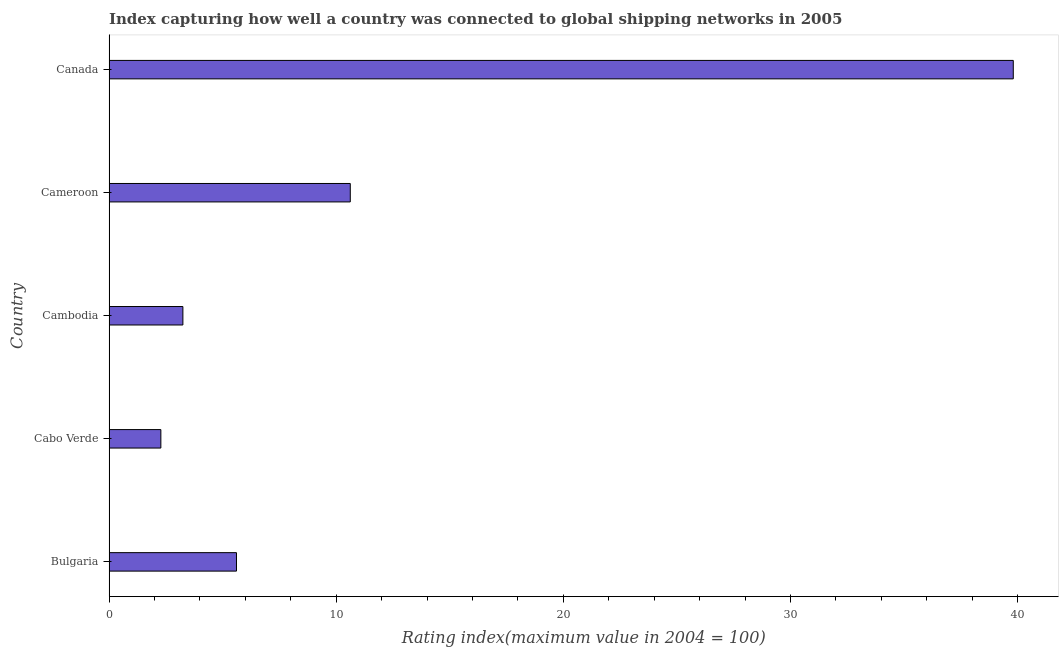Does the graph contain grids?
Keep it short and to the point. No. What is the title of the graph?
Provide a short and direct response. Index capturing how well a country was connected to global shipping networks in 2005. What is the label or title of the X-axis?
Keep it short and to the point. Rating index(maximum value in 2004 = 100). What is the label or title of the Y-axis?
Your answer should be very brief. Country. What is the liner shipping connectivity index in Cambodia?
Make the answer very short. 3.25. Across all countries, what is the maximum liner shipping connectivity index?
Make the answer very short. 39.81. Across all countries, what is the minimum liner shipping connectivity index?
Give a very brief answer. 2.28. In which country was the liner shipping connectivity index minimum?
Offer a very short reply. Cabo Verde. What is the sum of the liner shipping connectivity index?
Offer a terse response. 61.57. What is the difference between the liner shipping connectivity index in Bulgaria and Cambodia?
Ensure brevity in your answer.  2.36. What is the average liner shipping connectivity index per country?
Ensure brevity in your answer.  12.31. What is the median liner shipping connectivity index?
Ensure brevity in your answer.  5.61. In how many countries, is the liner shipping connectivity index greater than 4 ?
Your answer should be compact. 3. What is the ratio of the liner shipping connectivity index in Cameroon to that in Canada?
Your answer should be compact. 0.27. Is the liner shipping connectivity index in Cabo Verde less than that in Cambodia?
Give a very brief answer. Yes. What is the difference between the highest and the second highest liner shipping connectivity index?
Offer a terse response. 29.19. What is the difference between the highest and the lowest liner shipping connectivity index?
Your answer should be compact. 37.53. Are all the bars in the graph horizontal?
Your answer should be very brief. Yes. What is the Rating index(maximum value in 2004 = 100) in Bulgaria?
Offer a terse response. 5.61. What is the Rating index(maximum value in 2004 = 100) in Cabo Verde?
Make the answer very short. 2.28. What is the Rating index(maximum value in 2004 = 100) of Cambodia?
Give a very brief answer. 3.25. What is the Rating index(maximum value in 2004 = 100) of Cameroon?
Keep it short and to the point. 10.62. What is the Rating index(maximum value in 2004 = 100) of Canada?
Provide a short and direct response. 39.81. What is the difference between the Rating index(maximum value in 2004 = 100) in Bulgaria and Cabo Verde?
Ensure brevity in your answer.  3.33. What is the difference between the Rating index(maximum value in 2004 = 100) in Bulgaria and Cambodia?
Provide a succinct answer. 2.36. What is the difference between the Rating index(maximum value in 2004 = 100) in Bulgaria and Cameroon?
Offer a very short reply. -5.01. What is the difference between the Rating index(maximum value in 2004 = 100) in Bulgaria and Canada?
Ensure brevity in your answer.  -34.2. What is the difference between the Rating index(maximum value in 2004 = 100) in Cabo Verde and Cambodia?
Ensure brevity in your answer.  -0.97. What is the difference between the Rating index(maximum value in 2004 = 100) in Cabo Verde and Cameroon?
Your answer should be very brief. -8.34. What is the difference between the Rating index(maximum value in 2004 = 100) in Cabo Verde and Canada?
Offer a terse response. -37.53. What is the difference between the Rating index(maximum value in 2004 = 100) in Cambodia and Cameroon?
Make the answer very short. -7.37. What is the difference between the Rating index(maximum value in 2004 = 100) in Cambodia and Canada?
Keep it short and to the point. -36.56. What is the difference between the Rating index(maximum value in 2004 = 100) in Cameroon and Canada?
Offer a terse response. -29.19. What is the ratio of the Rating index(maximum value in 2004 = 100) in Bulgaria to that in Cabo Verde?
Your answer should be very brief. 2.46. What is the ratio of the Rating index(maximum value in 2004 = 100) in Bulgaria to that in Cambodia?
Provide a succinct answer. 1.73. What is the ratio of the Rating index(maximum value in 2004 = 100) in Bulgaria to that in Cameroon?
Give a very brief answer. 0.53. What is the ratio of the Rating index(maximum value in 2004 = 100) in Bulgaria to that in Canada?
Make the answer very short. 0.14. What is the ratio of the Rating index(maximum value in 2004 = 100) in Cabo Verde to that in Cambodia?
Ensure brevity in your answer.  0.7. What is the ratio of the Rating index(maximum value in 2004 = 100) in Cabo Verde to that in Cameroon?
Offer a terse response. 0.21. What is the ratio of the Rating index(maximum value in 2004 = 100) in Cabo Verde to that in Canada?
Make the answer very short. 0.06. What is the ratio of the Rating index(maximum value in 2004 = 100) in Cambodia to that in Cameroon?
Keep it short and to the point. 0.31. What is the ratio of the Rating index(maximum value in 2004 = 100) in Cambodia to that in Canada?
Offer a very short reply. 0.08. What is the ratio of the Rating index(maximum value in 2004 = 100) in Cameroon to that in Canada?
Your answer should be very brief. 0.27. 